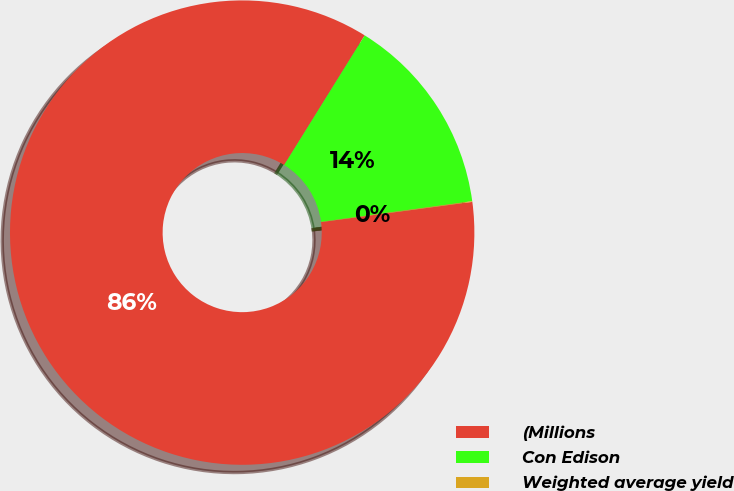<chart> <loc_0><loc_0><loc_500><loc_500><pie_chart><fcel>(Millions<fcel>Con Edison<fcel>Weighted average yield<nl><fcel>85.96%<fcel>13.99%<fcel>0.05%<nl></chart> 